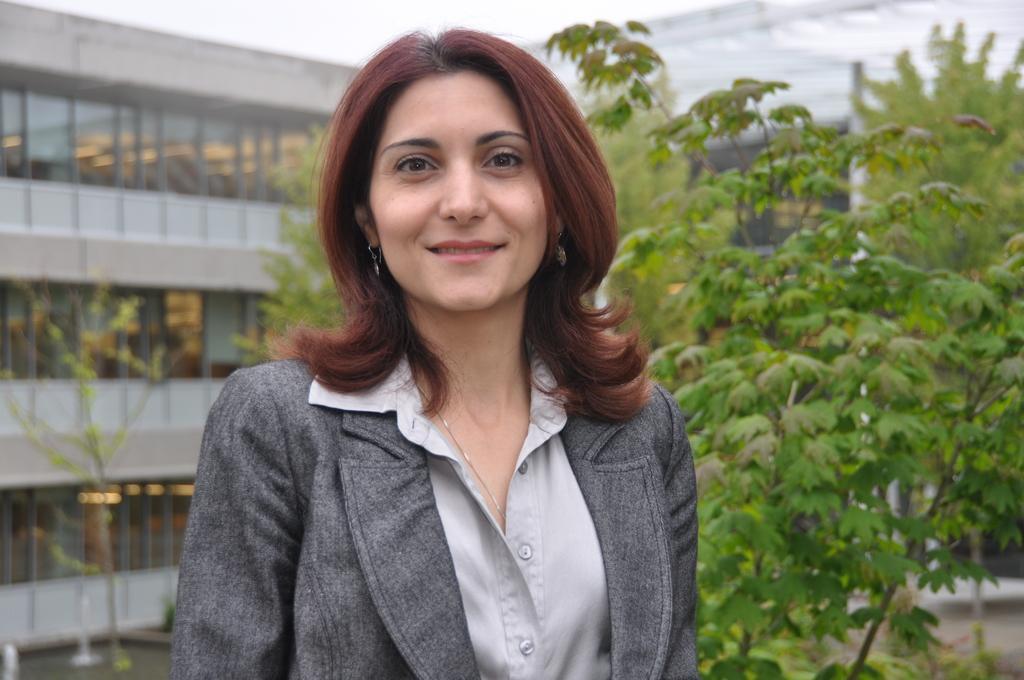How would you summarize this image in a sentence or two? In the center of the image there is a woman. In the background we can see building, plants, trees, and sky. 